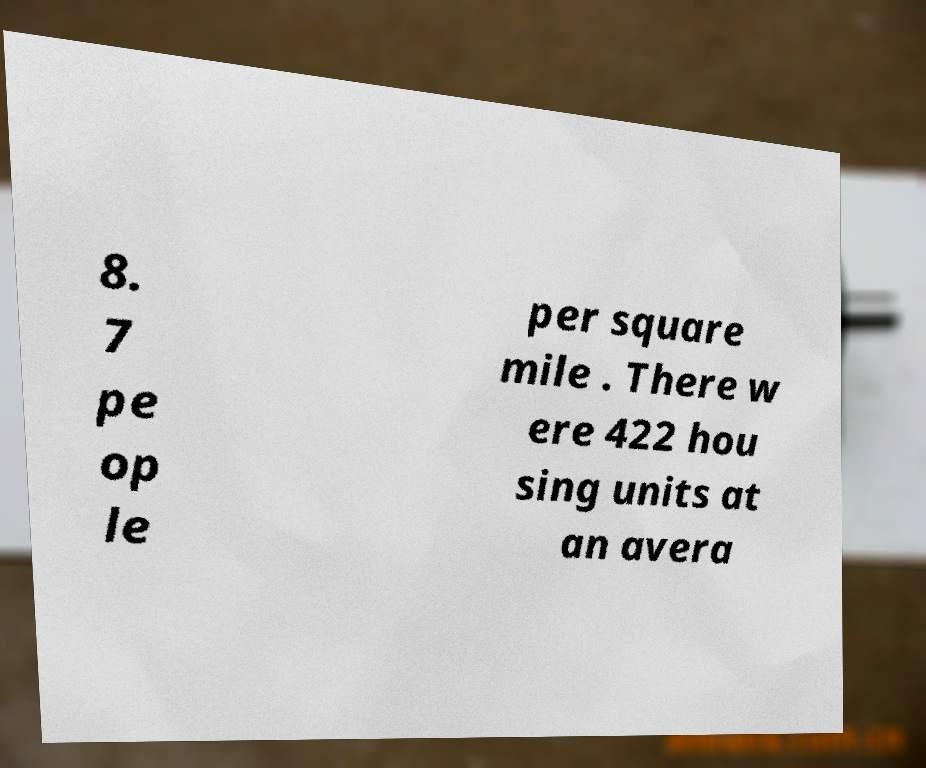Can you read and provide the text displayed in the image?This photo seems to have some interesting text. Can you extract and type it out for me? 8. 7 pe op le per square mile . There w ere 422 hou sing units at an avera 